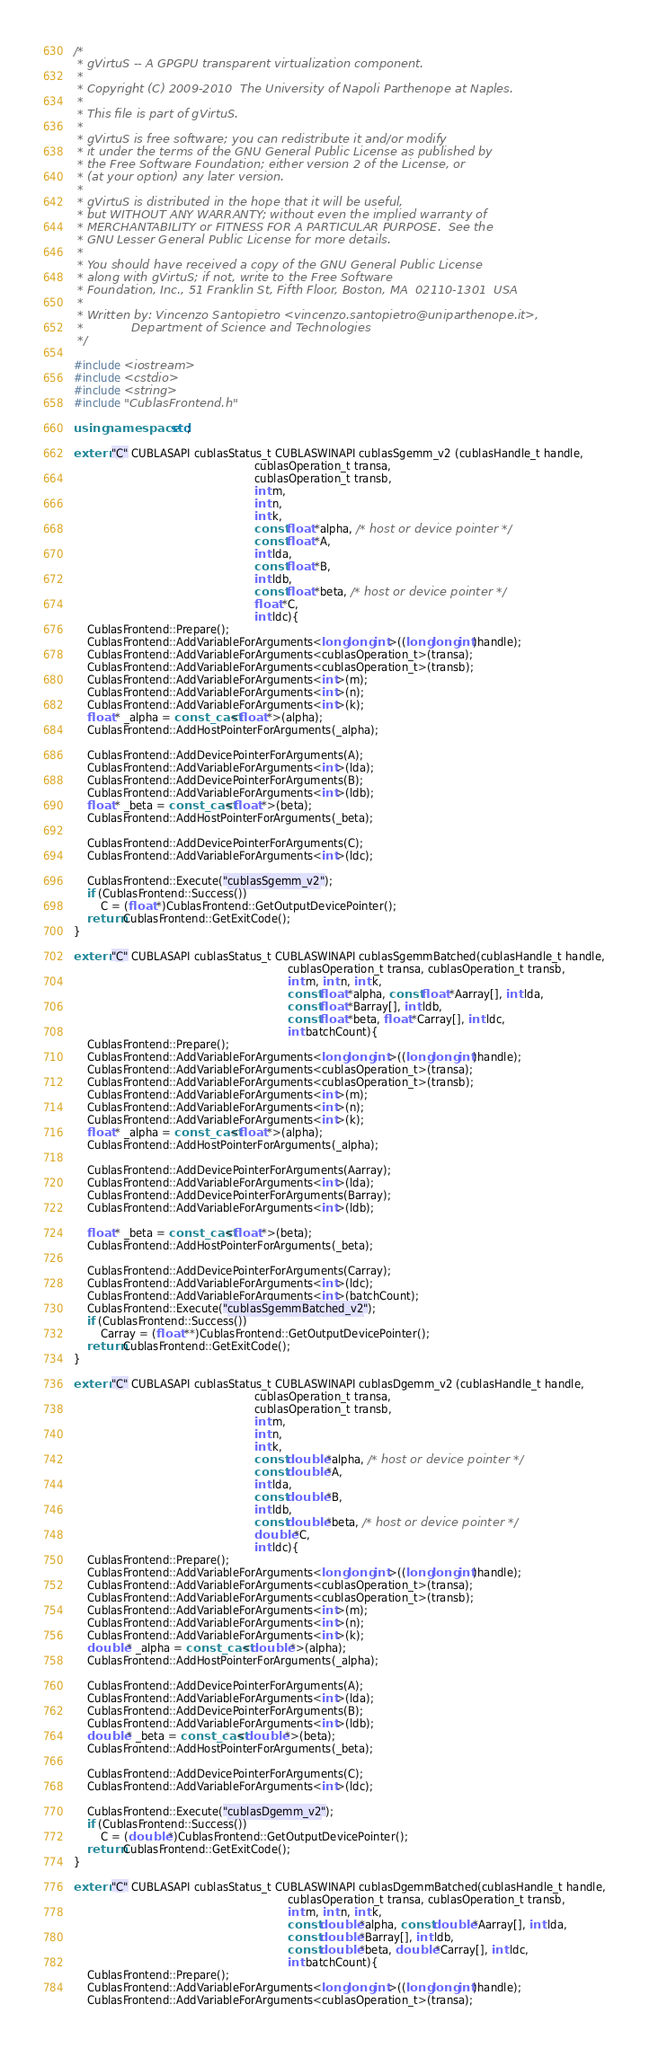<code> <loc_0><loc_0><loc_500><loc_500><_C++_>/*
 * gVirtuS -- A GPGPU transparent virtualization component.
 *
 * Copyright (C) 2009-2010  The University of Napoli Parthenope at Naples.
 *
 * This file is part of gVirtuS.
 *
 * gVirtuS is free software; you can redistribute it and/or modify
 * it under the terms of the GNU General Public License as published by
 * the Free Software Foundation; either version 2 of the License, or
 * (at your option) any later version.
 *
 * gVirtuS is distributed in the hope that it will be useful,
 * but WITHOUT ANY WARRANTY; without even the implied warranty of
 * MERCHANTABILITY or FITNESS FOR A PARTICULAR PURPOSE.  See the
 * GNU Lesser General Public License for more details.
 *
 * You should have received a copy of the GNU General Public License
 * along with gVirtuS; if not, write to the Free Software
 * Foundation, Inc., 51 Franklin St, Fifth Floor, Boston, MA  02110-1301  USA
 *
 * Written by: Vincenzo Santopietro <vincenzo.santopietro@uniparthenope.it>,
 *             Department of Science and Technologies
 */

#include <iostream>
#include <cstdio>
#include <string>
#include "CublasFrontend.h"

using namespace std;

extern "C" CUBLASAPI cublasStatus_t CUBLASWINAPI cublasSgemm_v2 (cublasHandle_t handle, 
                                                      cublasOperation_t transa,
                                                      cublasOperation_t transb, 
                                                      int m,
                                                      int n,
                                                      int k,
                                                      const float *alpha, /* host or device pointer */  
                                                      const float *A, 
                                                      int lda,
                                                      const float *B,
                                                      int ldb, 
                                                      const float *beta, /* host or device pointer */  
                                                      float *C,
                                                      int ldc){
    CublasFrontend::Prepare();
    CublasFrontend::AddVariableForArguments<long long int>((long long int)handle);
    CublasFrontend::AddVariableForArguments<cublasOperation_t>(transa);
    CublasFrontend::AddVariableForArguments<cublasOperation_t>(transb);
    CublasFrontend::AddVariableForArguments<int>(m);
    CublasFrontend::AddVariableForArguments<int>(n);
    CublasFrontend::AddVariableForArguments<int>(k);
    float * _alpha = const_cast<float *>(alpha);
    CublasFrontend::AddHostPointerForArguments(_alpha);
    
    CublasFrontend::AddDevicePointerForArguments(A);
    CublasFrontend::AddVariableForArguments<int>(lda);
    CublasFrontend::AddDevicePointerForArguments(B);
    CublasFrontend::AddVariableForArguments<int>(ldb);
    float * _beta = const_cast<float *>(beta);
    CublasFrontend::AddHostPointerForArguments(_beta);
    
    CublasFrontend::AddDevicePointerForArguments(C);
    CublasFrontend::AddVariableForArguments<int>(ldc);
    
    CublasFrontend::Execute("cublasSgemm_v2");
    if (CublasFrontend::Success())
        C = (float *)CublasFrontend::GetOutputDevicePointer();
    return CublasFrontend::GetExitCode();
}

extern "C" CUBLASAPI cublasStatus_t CUBLASWINAPI cublasSgemmBatched(cublasHandle_t handle,
                                                                cublasOperation_t transa, cublasOperation_t transb,
                                                                int m, int n, int k,
                                                                const float *alpha, const float *Aarray[], int lda,
                                                                const float *Barray[], int ldb,
                                                                const float *beta, float *Carray[], int ldc,
                                                                int batchCount){
    CublasFrontend::Prepare();
    CublasFrontend::AddVariableForArguments<long long int>((long long int)handle);
    CublasFrontend::AddVariableForArguments<cublasOperation_t>(transa);
    CublasFrontend::AddVariableForArguments<cublasOperation_t>(transb);
    CublasFrontend::AddVariableForArguments<int>(m);
    CublasFrontend::AddVariableForArguments<int>(n);
    CublasFrontend::AddVariableForArguments<int>(k);
    float * _alpha = const_cast<float *>(alpha);
    CublasFrontend::AddHostPointerForArguments(_alpha);
    
    CublasFrontend::AddDevicePointerForArguments(Aarray);
    CublasFrontend::AddVariableForArguments<int>(lda);
    CublasFrontend::AddDevicePointerForArguments(Barray);
    CublasFrontend::AddVariableForArguments<int>(ldb);
    
    float * _beta = const_cast<float *>(beta);
    CublasFrontend::AddHostPointerForArguments(_beta);
    
    CublasFrontend::AddDevicePointerForArguments(Carray);
    CublasFrontend::AddVariableForArguments<int>(ldc);
    CublasFrontend::AddVariableForArguments<int>(batchCount);
    CublasFrontend::Execute("cublasSgemmBatched_v2");
    if (CublasFrontend::Success())
        Carray = (float **)CublasFrontend::GetOutputDevicePointer();
    return CublasFrontend::GetExitCode();
}

extern "C" CUBLASAPI cublasStatus_t CUBLASWINAPI cublasDgemm_v2 (cublasHandle_t handle, 
                                                      cublasOperation_t transa,
                                                      cublasOperation_t transb, 
                                                      int m,
                                                      int n,
                                                      int k,
                                                      const double *alpha, /* host or device pointer */  
                                                      const double *A, 
                                                      int lda,
                                                      const double *B,
                                                      int ldb, 
                                                      const double *beta, /* host or device pointer */  
                                                      double *C,
                                                      int ldc){
    CublasFrontend::Prepare();
    CublasFrontend::AddVariableForArguments<long long int>((long long int)handle);
    CublasFrontend::AddVariableForArguments<cublasOperation_t>(transa);
    CublasFrontend::AddVariableForArguments<cublasOperation_t>(transb);
    CublasFrontend::AddVariableForArguments<int>(m);
    CublasFrontend::AddVariableForArguments<int>(n);
    CublasFrontend::AddVariableForArguments<int>(k);
    double * _alpha = const_cast<double *>(alpha);
    CublasFrontend::AddHostPointerForArguments(_alpha);
    
    CublasFrontend::AddDevicePointerForArguments(A);
    CublasFrontend::AddVariableForArguments<int>(lda);
    CublasFrontend::AddDevicePointerForArguments(B);
    CublasFrontend::AddVariableForArguments<int>(ldb);
    double * _beta = const_cast<double *>(beta);
    CublasFrontend::AddHostPointerForArguments(_beta);
    
    CublasFrontend::AddDevicePointerForArguments(C);
    CublasFrontend::AddVariableForArguments<int>(ldc);
    
    CublasFrontend::Execute("cublasDgemm_v2");
    if (CublasFrontend::Success())
        C = (double *)CublasFrontend::GetOutputDevicePointer();
    return CublasFrontend::GetExitCode();
}

extern "C" CUBLASAPI cublasStatus_t CUBLASWINAPI cublasDgemmBatched(cublasHandle_t handle,
                                                                cublasOperation_t transa, cublasOperation_t transb,
                                                                int m, int n, int k,
                                                                const double *alpha, const double *Aarray[], int lda,
                                                                const double *Barray[], int ldb,
                                                                const double *beta, double *Carray[], int ldc,
                                                                int batchCount){
    CublasFrontend::Prepare();
    CublasFrontend::AddVariableForArguments<long long int>((long long int)handle);
    CublasFrontend::AddVariableForArguments<cublasOperation_t>(transa);</code> 